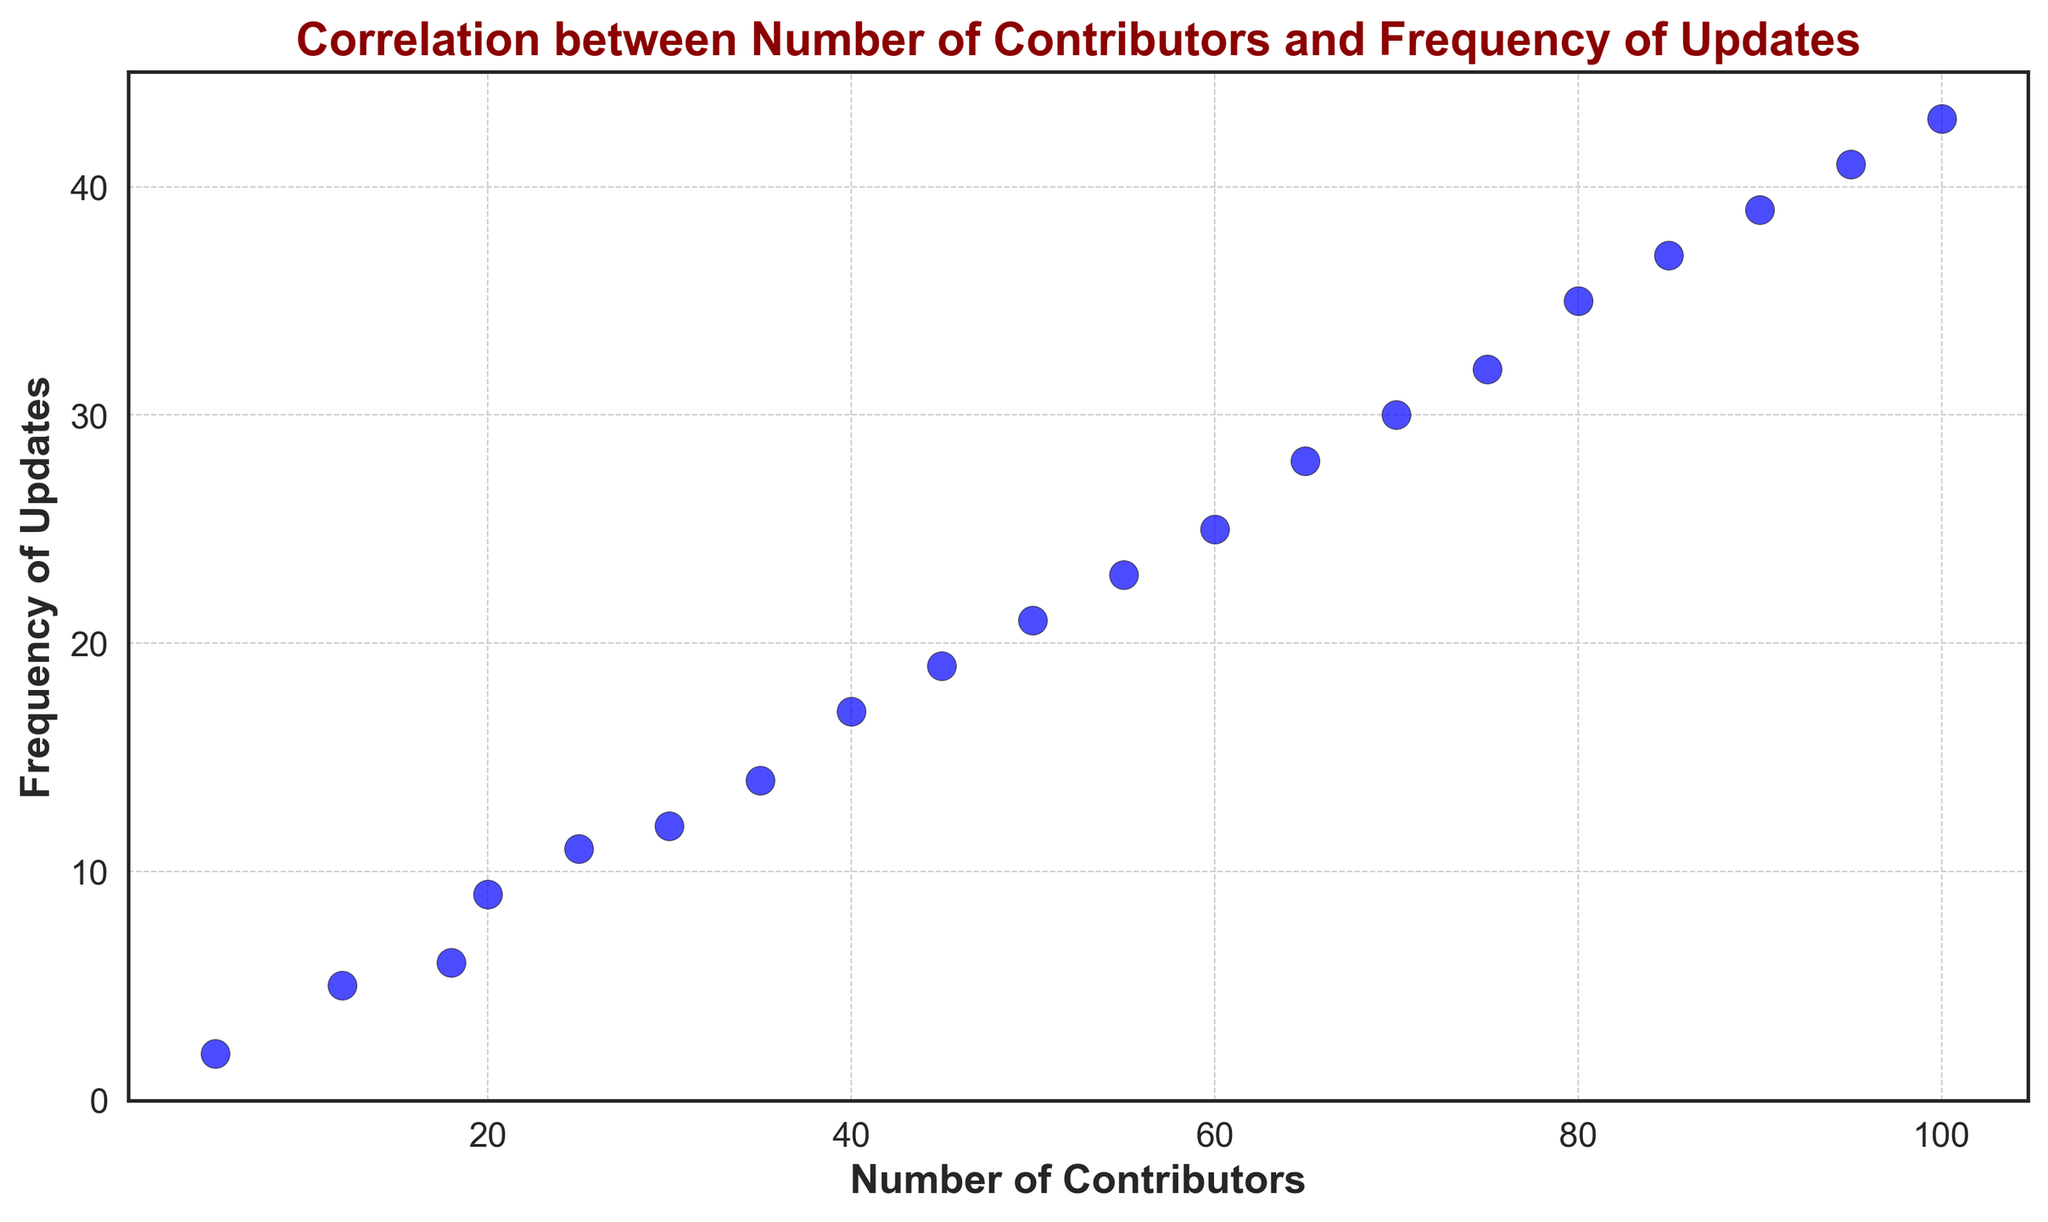What's the minimum number of contributors on the graph? The graph shows a scatter plot with the number of contributors on the x-axis. The leftmost point indicates the minimum number of contributors, which is 5.
Answer: 5 Which data point corresponds to the maximum frequency of updates? Look for the highest point on the y-axis, which is the maximum frequency of updates. The highest point is at frequency 43, corresponding to 100 contributors.
Answer: 100 Is there a positive correlation between the number of contributors and the frequency of updates? Observing the scatter plot, you can see that as the number of contributors increases, the frequency of updates also increases. This indicates a positive correlation.
Answer: Yes What is the frequency of updates when there are 50 contributors? Locate the data point above 50 on the x-axis and check the corresponding y-axis value. The frequency of updates for 50 contributors is 21.
Answer: 21 By how much does the frequency of updates increase between having 10 contributors and 60 contributors? Find the data points for 10 contributors (frequency 5) and 60 contributors (frequency 25). Subtract the smaller frequency from the larger one: 25 - 5 = 20.
Answer: 20 By what factor does the frequency of updates increase when the number of contributors increases from 5 to 100? Calculate the initial and final frequencies for 5 (frequency 2) and 100 (frequency 43). Find the ratio: 43 / 2 = 21.5.
Answer: 21.5 At how many contributors does the frequency of updates reach 30? Locate the point with frequency 30 on the y-axis and find the corresponding x-axis value, which is the number of contributors. This corresponds to 70 contributors.
Answer: 70 What is the average frequency of updates for projects with 40, 60, and 80 contributors? Locate the frequencies for 40 (17), 60 (25), and 80 (35) contributors. Sum them: 17 + 25 + 35 = 77. Divide by 3 to get the average: 77 / 3 ≈ 25.67.
Answer: 25.67 How does the trend of the plotted points suggest the relationship between the two variables? The scatter plot shows an upward trend with points clustering closer to a straight line, suggesting a linear relationship where an increase in the number of contributors leads to a proportionate increase in the frequency of updates.
Answer: Proportional increase 